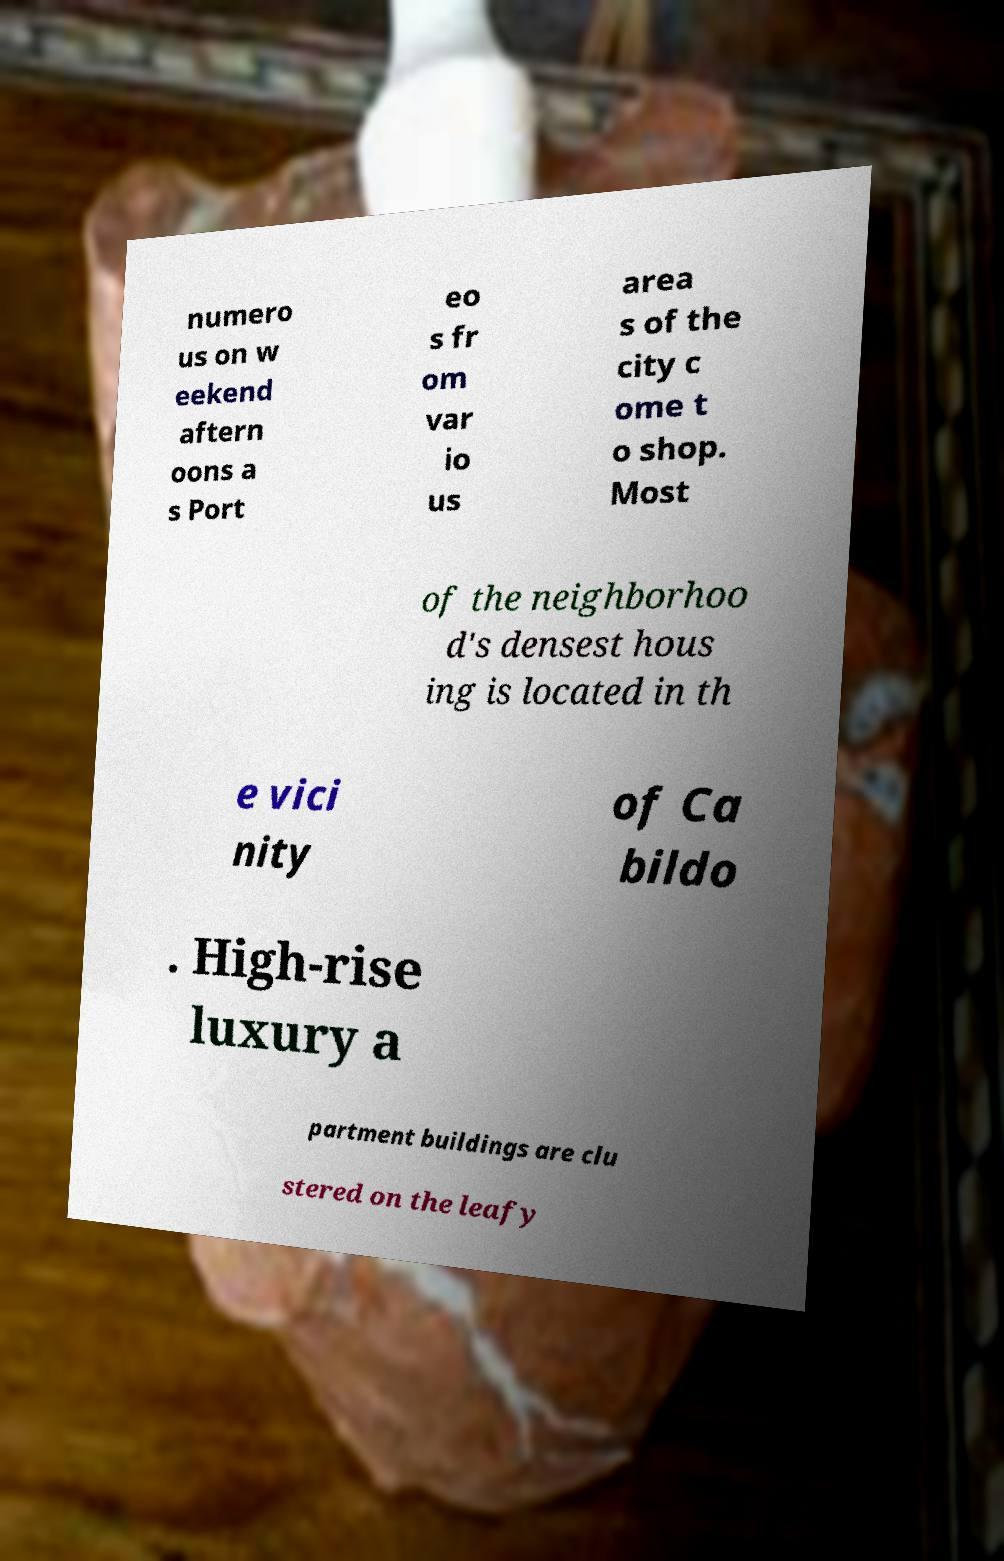Could you extract and type out the text from this image? numero us on w eekend aftern oons a s Port eo s fr om var io us area s of the city c ome t o shop. Most of the neighborhoo d's densest hous ing is located in th e vici nity of Ca bildo . High-rise luxury a partment buildings are clu stered on the leafy 